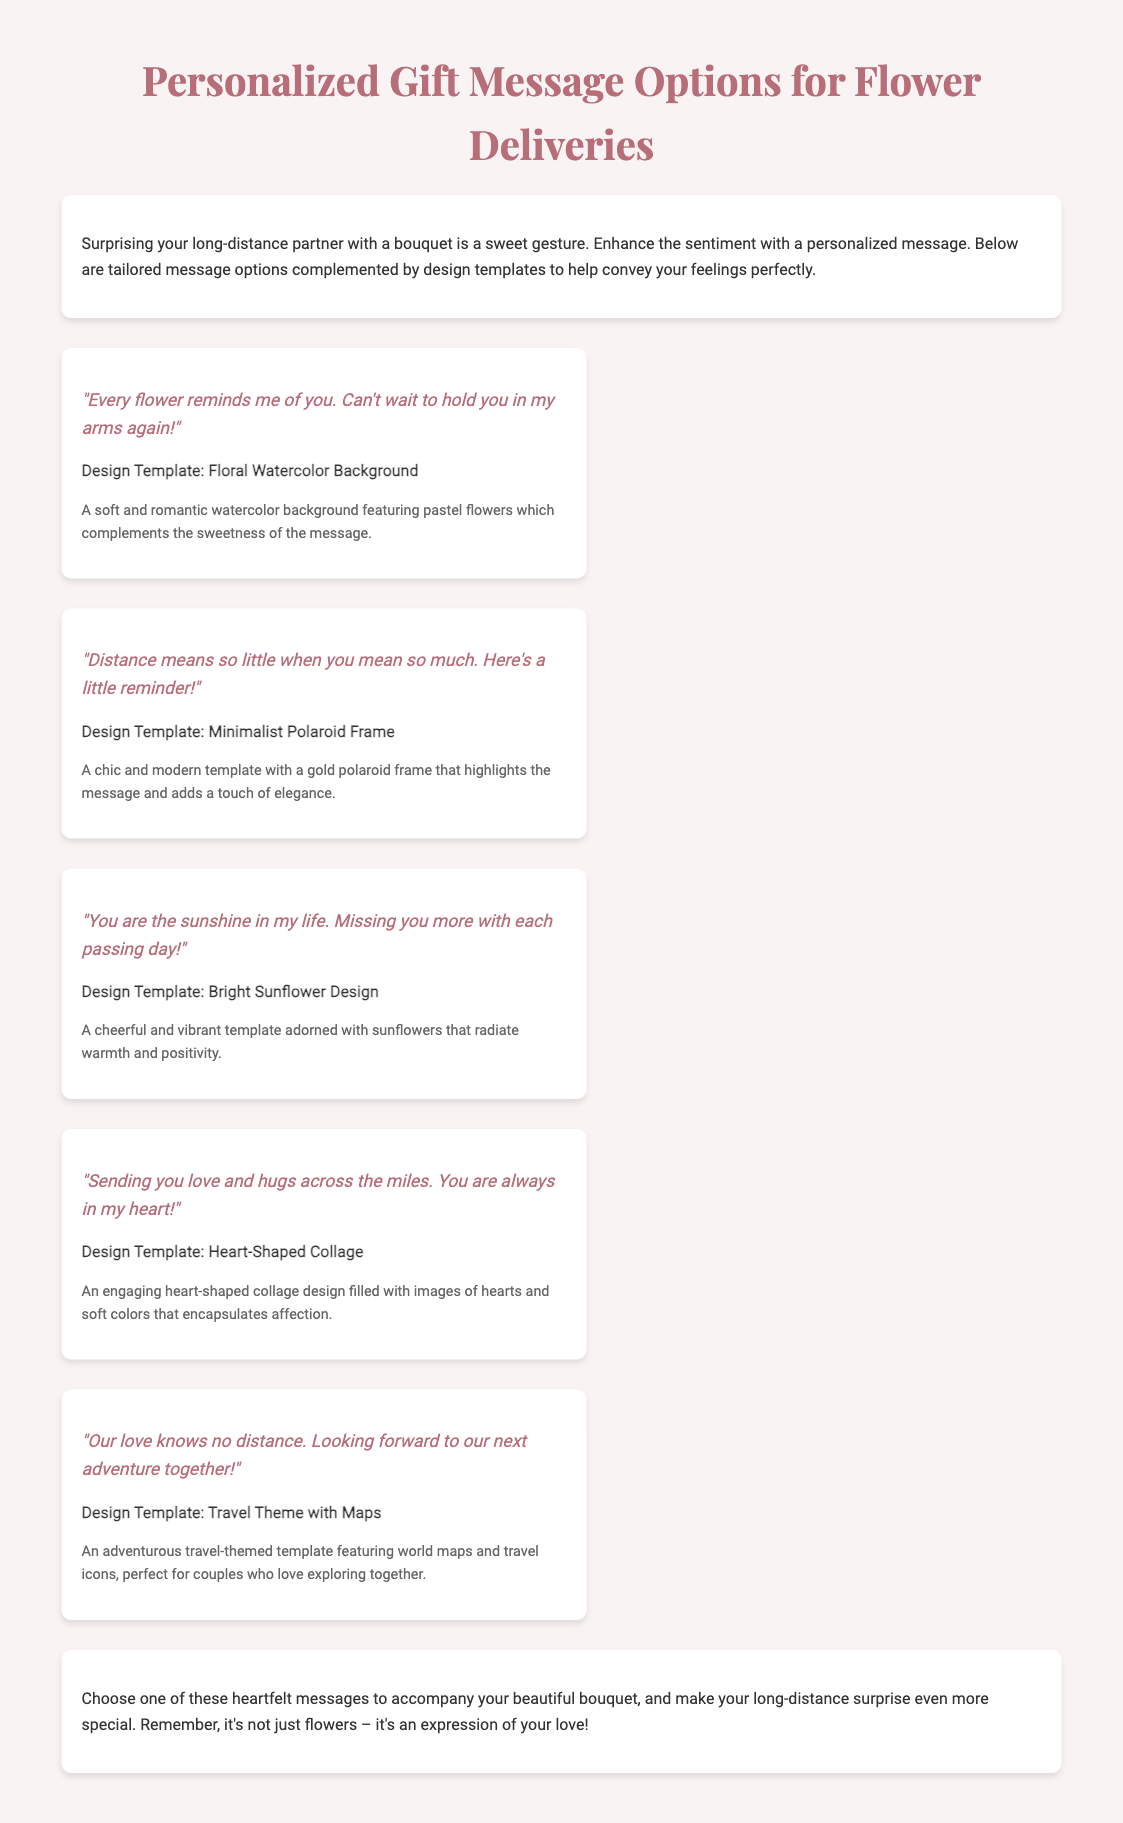what is the title of the document? The title is shown prominently at the top of the document.
Answer: Personalized Gift Message Options for Flower Deliveries how many personalized message options are listed? The document includes a section that lists different message options.
Answer: Five what is the message for the "Floral Watercolor Background" design template? The specific message associated with this design template is provided in the content.
Answer: "Every flower reminds me of you. Can't wait to hold you in my arms again!" which design template features sunflowers? The document clearly states the design templates associated with each message option.
Answer: Bright Sunflower Design what is the overall purpose of the document? The introduction clearly states the main objective of the document.
Answer: To enhance the sentiment of flower deliveries with personalized messages what does the heart-shaped collage design convey? The description of this design template indicates its emotional significance.
Answer: Affection which message indicates a longing for a shared adventure? The wording of one message clearly expresses this sentiment about adventure.
Answer: "Our love knows no distance. Looking forward to our next adventure together!" what color theme is used in the "Minimalist Polaroid Frame" design? The document discusses the visual characteristics of this design template.
Answer: Gold 